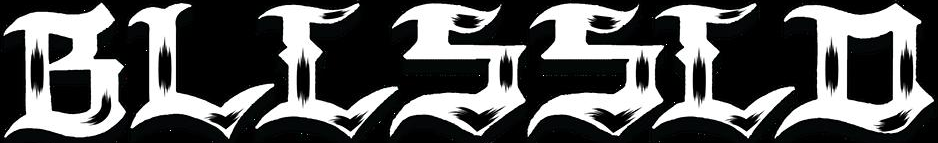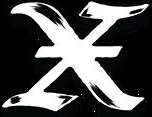What text is displayed in these images sequentially, separated by a semicolon? BLLSSLD; X 